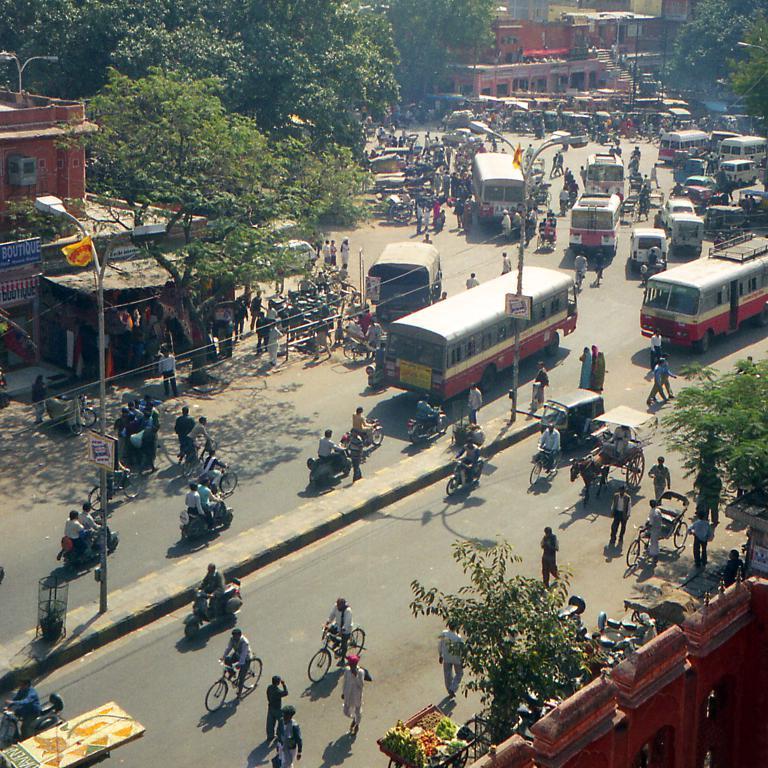What is on the sign in blue?
Your answer should be compact. Boutique. 